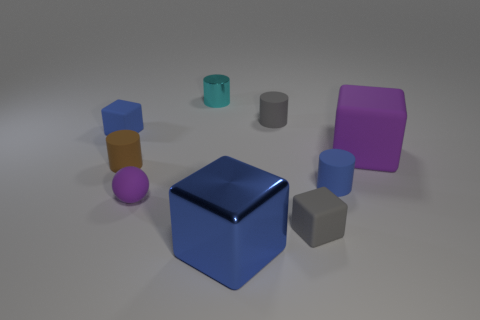There is a object that is the same color as the sphere; what is its shape?
Keep it short and to the point. Cube. Are there any tiny blue things that have the same material as the tiny gray block?
Make the answer very short. Yes. The sphere that is the same color as the large matte cube is what size?
Give a very brief answer. Small. What number of cylinders are purple things or tiny objects?
Offer a very short reply. 4. What size is the blue shiny thing?
Ensure brevity in your answer.  Large. What number of large shiny cubes are on the right side of the small brown rubber cylinder?
Give a very brief answer. 1. There is a matte object behind the tiny blue block behind the matte ball; what is its size?
Ensure brevity in your answer.  Small. Do the large thing to the right of the large metallic block and the tiny blue matte thing that is behind the brown object have the same shape?
Your answer should be compact. Yes. What is the shape of the small rubber object behind the small blue rubber object that is to the left of the shiny cylinder?
Make the answer very short. Cylinder. What size is the blue object that is on the left side of the tiny gray cylinder and on the right side of the tiny cyan thing?
Keep it short and to the point. Large. 